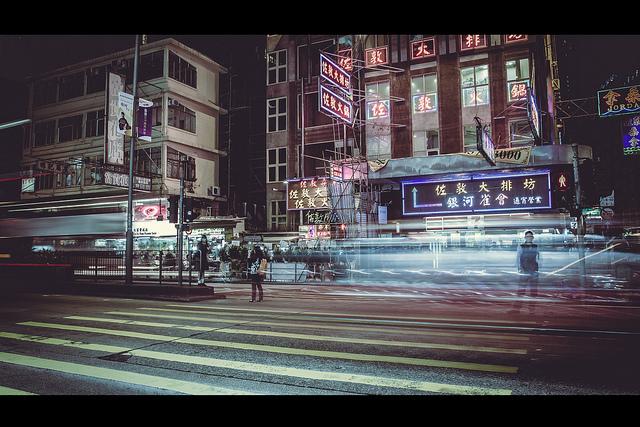What effect was used in this photo?
Be succinct. Blur. What country is this?
Quick response, please. China. What does the neon sign say?
Short answer required. Food. Where was this photo taken?
Keep it brief. Asia. What team is on the billboard?
Quick response, please. Unknown. Is anyone walking toward the camera?
Write a very short answer. Yes. Is this the ground?
Concise answer only. Yes. What food does the restaurant serve?
Short answer required. Chinese food. Which city is this?
Short answer required. Tokyo. What restaurant is in the picture?
Answer briefly. Chinese. What are the lights from?
Answer briefly. Signs. Is it raining?
Concise answer only. No. What kind of information is on the blue sign?
Keep it brief. Not sure. Are there any bananas?
Keep it brief. No. Is this phone taken in a European or Asian city?
Short answer required. Asian. Is it daytime outside?
Write a very short answer. No. At what angle was the picture taken?
Be succinct. Side. Are the signs in English?
Keep it brief. No. What city was this picture taken?
Concise answer only. Hong kong. What color is the stripe on the sidewalk?
Quick response, please. Yellow. 